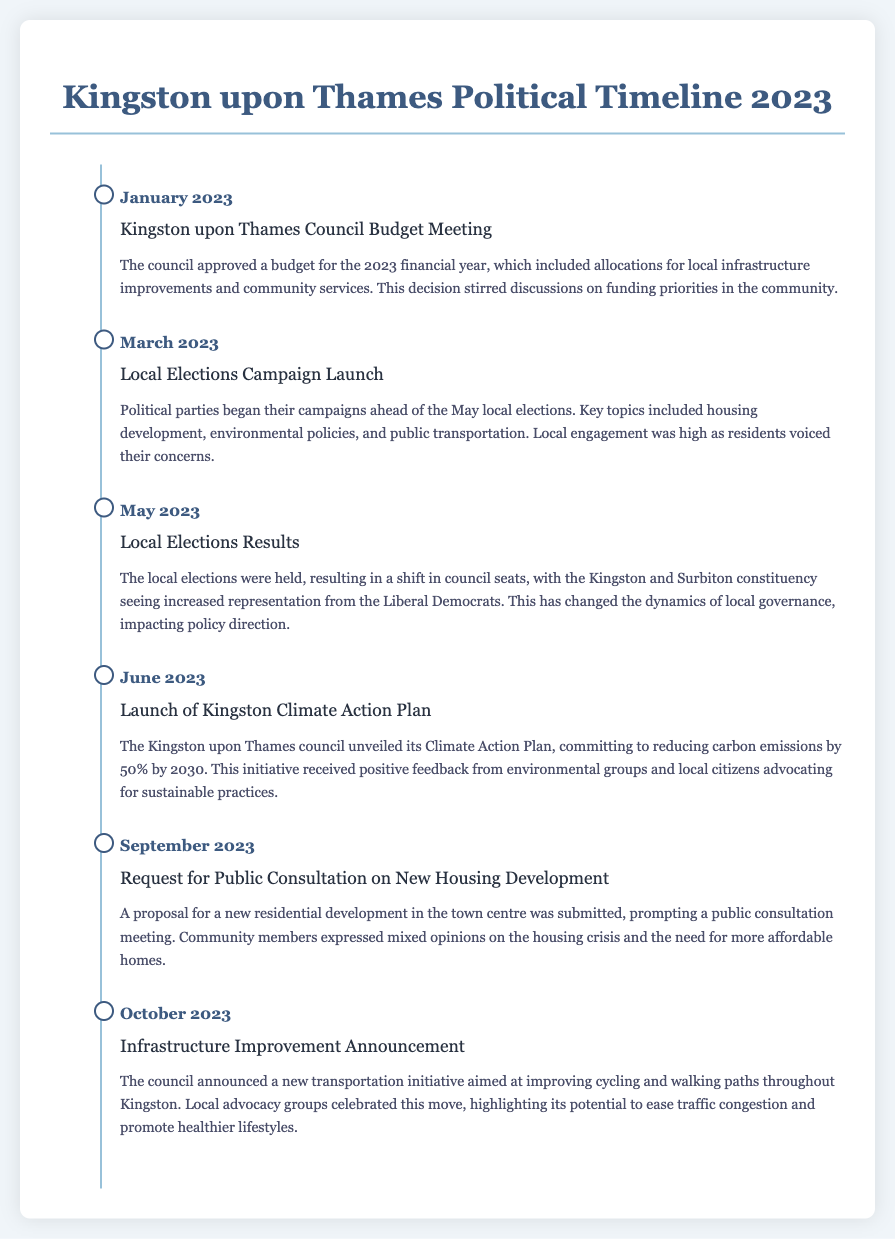What month was the Kingston upon Thames Council Budget Meeting held? The document states that the budget meeting took place in January 2023.
Answer: January 2023 Which political party gained increased representation in the May 2023 local elections? The results of the local elections indicated that the Liberal Democrats had increased representation.
Answer: Liberal Democrats What significant environmental initiative was launched in June 2023? The council unveiled its Climate Action Plan, which committed to reducing carbon emissions.
Answer: Climate Action Plan How much does the Kingston Climate Action Plan aim to reduce carbon emissions by 2030? The document specifies that the goal is to reduce carbon emissions by 50%.
Answer: 50% What was the primary focus of the public consultation held in September 2023? The consultation addressed a proposal for a new residential development in the town centre.
Answer: New housing development In which month was the Infrastructure Improvement Announcement made? The announcement about the new transportation initiative was made in October 2023.
Answer: October 2023 What community campaign topics were highlighted during the March 2023 local elections campaign launch? Key topics included housing development, environmental policies, and public transportation.
Answer: Housing development, environmental policies, public transportation What was a community reaction to the launch of the Climate Action Plan in June 2023? The initiative received positive feedback from environmental groups and local citizens.
Answer: Positive feedback 